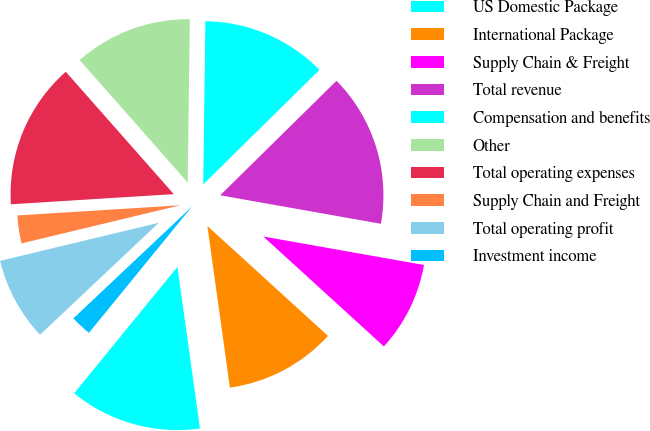Convert chart. <chart><loc_0><loc_0><loc_500><loc_500><pie_chart><fcel>US Domestic Package<fcel>International Package<fcel>Supply Chain & Freight<fcel>Total revenue<fcel>Compensation and benefits<fcel>Other<fcel>Total operating expenses<fcel>Supply Chain and Freight<fcel>Total operating profit<fcel>Investment income<nl><fcel>13.1%<fcel>11.03%<fcel>8.97%<fcel>15.17%<fcel>12.41%<fcel>11.72%<fcel>14.48%<fcel>2.76%<fcel>8.28%<fcel>2.07%<nl></chart> 